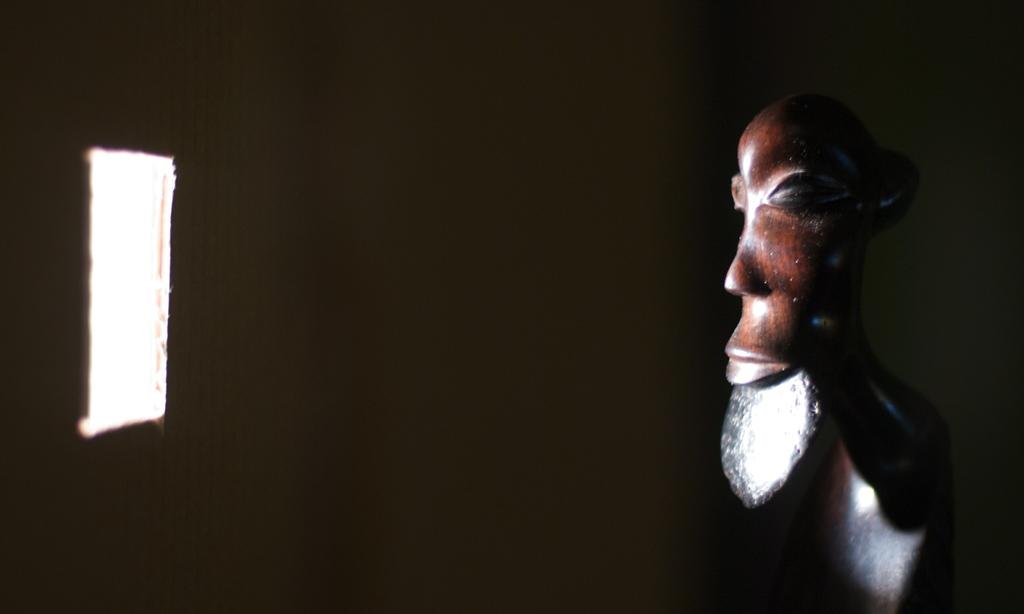What is the main subject of the image? There is a small wooden sculpture in the image. Can you describe any architectural features in the image? There is a small window in the image. How is the wooden sculpture being affected by the environment in the image? Sunlight is falling on the wooden sculpture through the window. What type of jeans is the wooden sculpture wearing in the image? There are no jeans present in the image, as the wooden sculpture is an inanimate object and does not wear clothing. 